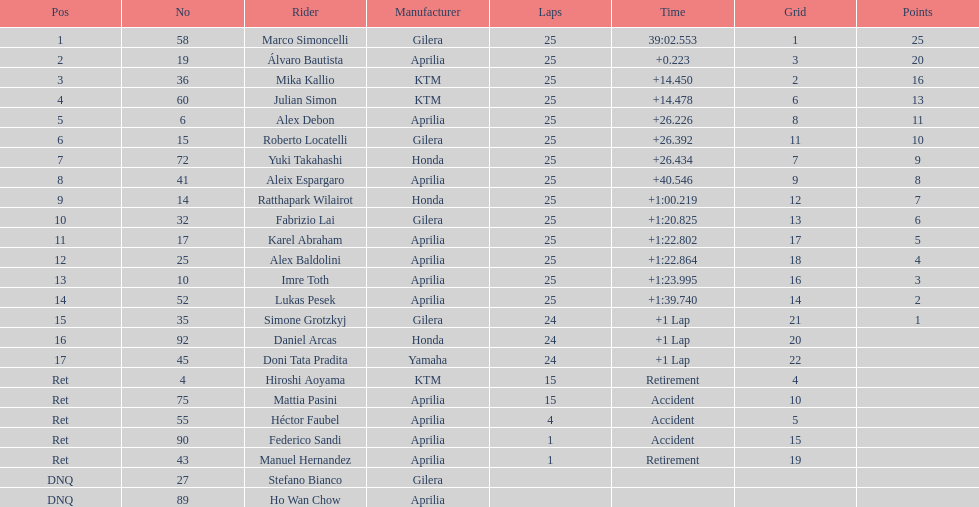In which nation can the greatest quantity of riders be found? Italy. 